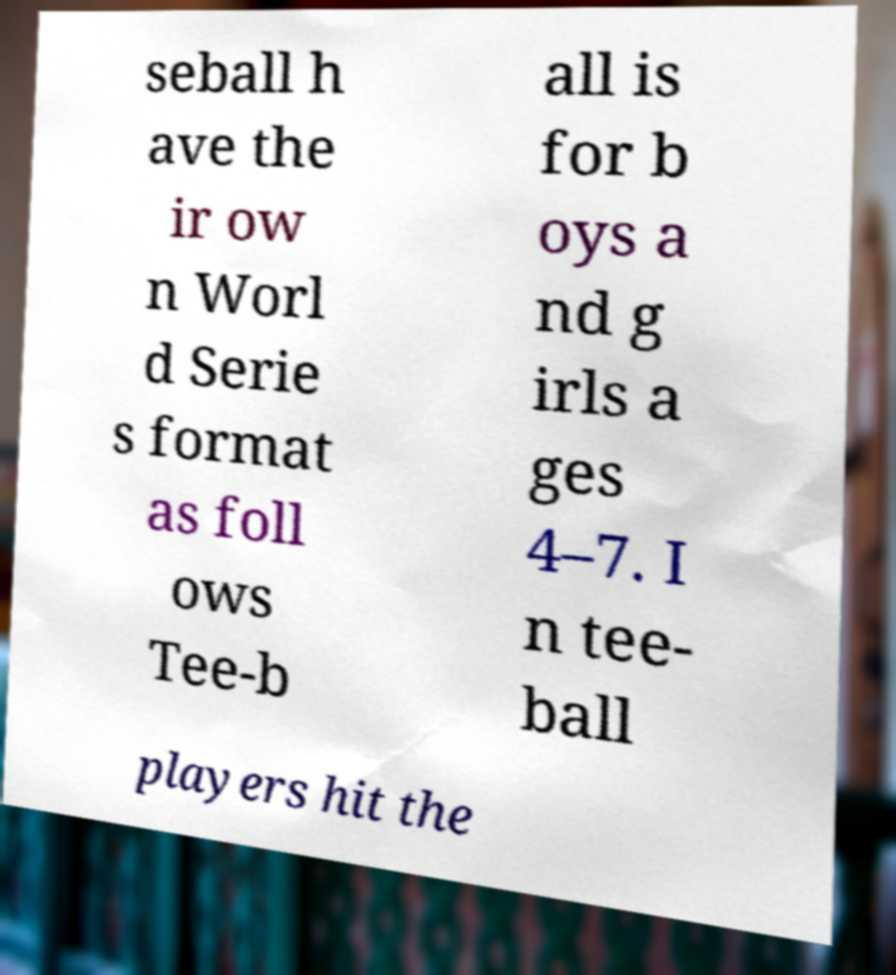Could you extract and type out the text from this image? seball h ave the ir ow n Worl d Serie s format as foll ows Tee-b all is for b oys a nd g irls a ges 4–7. I n tee- ball players hit the 